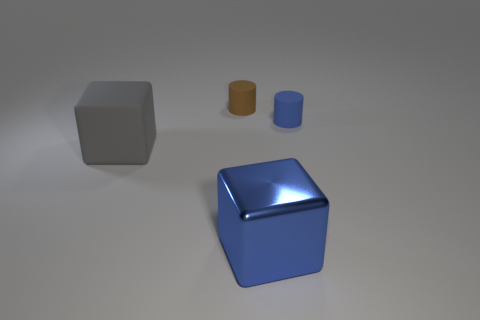Add 2 cubes. How many objects exist? 6 Add 3 tiny blue matte things. How many tiny blue matte things exist? 4 Subtract 0 gray spheres. How many objects are left? 4 Subtract all cylinders. Subtract all tiny brown things. How many objects are left? 1 Add 4 blue cylinders. How many blue cylinders are left? 5 